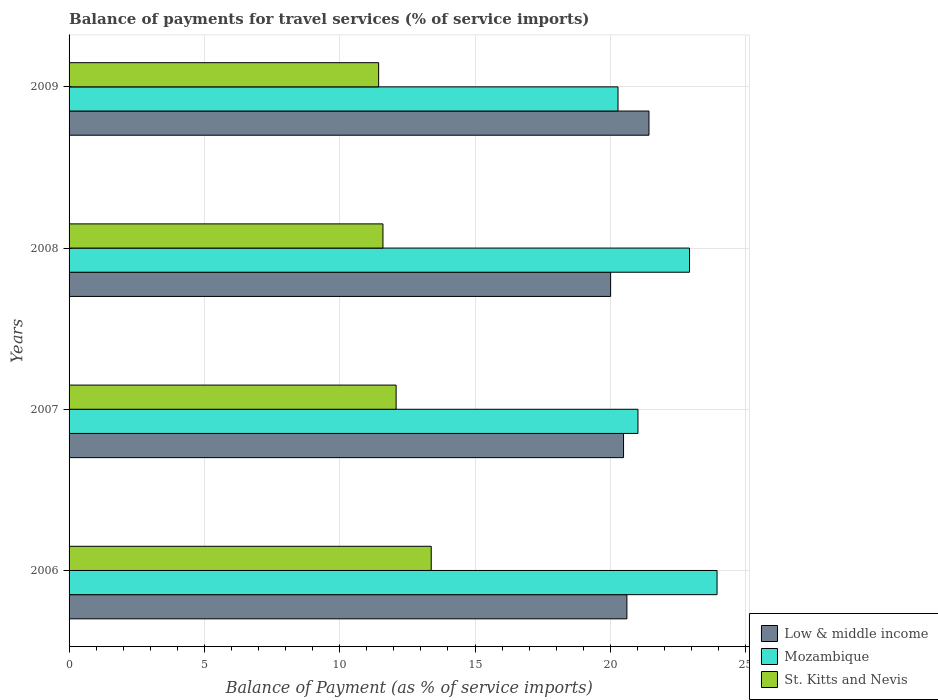How many different coloured bars are there?
Ensure brevity in your answer.  3. How many groups of bars are there?
Your answer should be compact. 4. Are the number of bars on each tick of the Y-axis equal?
Make the answer very short. Yes. How many bars are there on the 1st tick from the top?
Offer a terse response. 3. How many bars are there on the 3rd tick from the bottom?
Offer a terse response. 3. What is the label of the 2nd group of bars from the top?
Your answer should be compact. 2008. In how many cases, is the number of bars for a given year not equal to the number of legend labels?
Your answer should be very brief. 0. What is the balance of payments for travel services in Low & middle income in 2009?
Give a very brief answer. 21.43. Across all years, what is the maximum balance of payments for travel services in St. Kitts and Nevis?
Make the answer very short. 13.38. Across all years, what is the minimum balance of payments for travel services in Mozambique?
Offer a terse response. 20.28. In which year was the balance of payments for travel services in Low & middle income maximum?
Offer a terse response. 2009. What is the total balance of payments for travel services in Low & middle income in the graph?
Your answer should be very brief. 82.53. What is the difference between the balance of payments for travel services in Mozambique in 2006 and that in 2009?
Ensure brevity in your answer.  3.66. What is the difference between the balance of payments for travel services in Mozambique in 2008 and the balance of payments for travel services in St. Kitts and Nevis in 2007?
Ensure brevity in your answer.  10.84. What is the average balance of payments for travel services in Low & middle income per year?
Provide a short and direct response. 20.63. In the year 2006, what is the difference between the balance of payments for travel services in St. Kitts and Nevis and balance of payments for travel services in Mozambique?
Offer a terse response. -10.56. In how many years, is the balance of payments for travel services in St. Kitts and Nevis greater than 4 %?
Offer a terse response. 4. What is the ratio of the balance of payments for travel services in Mozambique in 2007 to that in 2009?
Offer a terse response. 1.04. Is the difference between the balance of payments for travel services in St. Kitts and Nevis in 2008 and 2009 greater than the difference between the balance of payments for travel services in Mozambique in 2008 and 2009?
Make the answer very short. No. What is the difference between the highest and the second highest balance of payments for travel services in Mozambique?
Keep it short and to the point. 1.02. What is the difference between the highest and the lowest balance of payments for travel services in Low & middle income?
Give a very brief answer. 1.42. In how many years, is the balance of payments for travel services in St. Kitts and Nevis greater than the average balance of payments for travel services in St. Kitts and Nevis taken over all years?
Provide a succinct answer. 1. What does the 2nd bar from the top in 2007 represents?
Provide a succinct answer. Mozambique. What does the 1st bar from the bottom in 2006 represents?
Provide a short and direct response. Low & middle income. Is it the case that in every year, the sum of the balance of payments for travel services in Low & middle income and balance of payments for travel services in St. Kitts and Nevis is greater than the balance of payments for travel services in Mozambique?
Your response must be concise. Yes. How many bars are there?
Give a very brief answer. 12. Are all the bars in the graph horizontal?
Ensure brevity in your answer.  Yes. How many years are there in the graph?
Offer a terse response. 4. What is the difference between two consecutive major ticks on the X-axis?
Your response must be concise. 5. What is the title of the graph?
Keep it short and to the point. Balance of payments for travel services (% of service imports). What is the label or title of the X-axis?
Provide a short and direct response. Balance of Payment (as % of service imports). What is the Balance of Payment (as % of service imports) of Low & middle income in 2006?
Ensure brevity in your answer.  20.61. What is the Balance of Payment (as % of service imports) of Mozambique in 2006?
Keep it short and to the point. 23.94. What is the Balance of Payment (as % of service imports) in St. Kitts and Nevis in 2006?
Ensure brevity in your answer.  13.38. What is the Balance of Payment (as % of service imports) in Low & middle income in 2007?
Your answer should be compact. 20.49. What is the Balance of Payment (as % of service imports) of Mozambique in 2007?
Give a very brief answer. 21.02. What is the Balance of Payment (as % of service imports) in St. Kitts and Nevis in 2007?
Make the answer very short. 12.08. What is the Balance of Payment (as % of service imports) in Low & middle income in 2008?
Provide a short and direct response. 20.01. What is the Balance of Payment (as % of service imports) of Mozambique in 2008?
Make the answer very short. 22.92. What is the Balance of Payment (as % of service imports) in St. Kitts and Nevis in 2008?
Provide a succinct answer. 11.6. What is the Balance of Payment (as % of service imports) of Low & middle income in 2009?
Your answer should be very brief. 21.43. What is the Balance of Payment (as % of service imports) of Mozambique in 2009?
Make the answer very short. 20.28. What is the Balance of Payment (as % of service imports) in St. Kitts and Nevis in 2009?
Your answer should be very brief. 11.44. Across all years, what is the maximum Balance of Payment (as % of service imports) of Low & middle income?
Your answer should be very brief. 21.43. Across all years, what is the maximum Balance of Payment (as % of service imports) in Mozambique?
Provide a short and direct response. 23.94. Across all years, what is the maximum Balance of Payment (as % of service imports) in St. Kitts and Nevis?
Provide a succinct answer. 13.38. Across all years, what is the minimum Balance of Payment (as % of service imports) of Low & middle income?
Offer a very short reply. 20.01. Across all years, what is the minimum Balance of Payment (as % of service imports) of Mozambique?
Give a very brief answer. 20.28. Across all years, what is the minimum Balance of Payment (as % of service imports) of St. Kitts and Nevis?
Your response must be concise. 11.44. What is the total Balance of Payment (as % of service imports) of Low & middle income in the graph?
Provide a succinct answer. 82.53. What is the total Balance of Payment (as % of service imports) of Mozambique in the graph?
Offer a terse response. 88.17. What is the total Balance of Payment (as % of service imports) in St. Kitts and Nevis in the graph?
Provide a short and direct response. 48.5. What is the difference between the Balance of Payment (as % of service imports) of Low & middle income in 2006 and that in 2007?
Provide a succinct answer. 0.12. What is the difference between the Balance of Payment (as % of service imports) of Mozambique in 2006 and that in 2007?
Keep it short and to the point. 2.92. What is the difference between the Balance of Payment (as % of service imports) of St. Kitts and Nevis in 2006 and that in 2007?
Your response must be concise. 1.3. What is the difference between the Balance of Payment (as % of service imports) in Low & middle income in 2006 and that in 2008?
Give a very brief answer. 0.6. What is the difference between the Balance of Payment (as % of service imports) in Mozambique in 2006 and that in 2008?
Offer a very short reply. 1.02. What is the difference between the Balance of Payment (as % of service imports) in St. Kitts and Nevis in 2006 and that in 2008?
Your answer should be compact. 1.78. What is the difference between the Balance of Payment (as % of service imports) of Low & middle income in 2006 and that in 2009?
Give a very brief answer. -0.81. What is the difference between the Balance of Payment (as % of service imports) in Mozambique in 2006 and that in 2009?
Give a very brief answer. 3.66. What is the difference between the Balance of Payment (as % of service imports) in St. Kitts and Nevis in 2006 and that in 2009?
Offer a terse response. 1.94. What is the difference between the Balance of Payment (as % of service imports) of Low & middle income in 2007 and that in 2008?
Provide a short and direct response. 0.48. What is the difference between the Balance of Payment (as % of service imports) of Mozambique in 2007 and that in 2008?
Your answer should be compact. -1.9. What is the difference between the Balance of Payment (as % of service imports) of St. Kitts and Nevis in 2007 and that in 2008?
Offer a very short reply. 0.49. What is the difference between the Balance of Payment (as % of service imports) in Low & middle income in 2007 and that in 2009?
Make the answer very short. -0.94. What is the difference between the Balance of Payment (as % of service imports) in Mozambique in 2007 and that in 2009?
Give a very brief answer. 0.74. What is the difference between the Balance of Payment (as % of service imports) in St. Kitts and Nevis in 2007 and that in 2009?
Offer a very short reply. 0.65. What is the difference between the Balance of Payment (as % of service imports) of Low & middle income in 2008 and that in 2009?
Offer a terse response. -1.42. What is the difference between the Balance of Payment (as % of service imports) in Mozambique in 2008 and that in 2009?
Provide a short and direct response. 2.64. What is the difference between the Balance of Payment (as % of service imports) of St. Kitts and Nevis in 2008 and that in 2009?
Provide a succinct answer. 0.16. What is the difference between the Balance of Payment (as % of service imports) of Low & middle income in 2006 and the Balance of Payment (as % of service imports) of Mozambique in 2007?
Your answer should be very brief. -0.41. What is the difference between the Balance of Payment (as % of service imports) of Low & middle income in 2006 and the Balance of Payment (as % of service imports) of St. Kitts and Nevis in 2007?
Ensure brevity in your answer.  8.53. What is the difference between the Balance of Payment (as % of service imports) in Mozambique in 2006 and the Balance of Payment (as % of service imports) in St. Kitts and Nevis in 2007?
Your answer should be very brief. 11.86. What is the difference between the Balance of Payment (as % of service imports) of Low & middle income in 2006 and the Balance of Payment (as % of service imports) of Mozambique in 2008?
Make the answer very short. -2.31. What is the difference between the Balance of Payment (as % of service imports) in Low & middle income in 2006 and the Balance of Payment (as % of service imports) in St. Kitts and Nevis in 2008?
Your answer should be compact. 9.01. What is the difference between the Balance of Payment (as % of service imports) in Mozambique in 2006 and the Balance of Payment (as % of service imports) in St. Kitts and Nevis in 2008?
Your answer should be compact. 12.34. What is the difference between the Balance of Payment (as % of service imports) in Low & middle income in 2006 and the Balance of Payment (as % of service imports) in Mozambique in 2009?
Your answer should be compact. 0.33. What is the difference between the Balance of Payment (as % of service imports) of Low & middle income in 2006 and the Balance of Payment (as % of service imports) of St. Kitts and Nevis in 2009?
Provide a short and direct response. 9.17. What is the difference between the Balance of Payment (as % of service imports) in Mozambique in 2006 and the Balance of Payment (as % of service imports) in St. Kitts and Nevis in 2009?
Your response must be concise. 12.5. What is the difference between the Balance of Payment (as % of service imports) of Low & middle income in 2007 and the Balance of Payment (as % of service imports) of Mozambique in 2008?
Your response must be concise. -2.44. What is the difference between the Balance of Payment (as % of service imports) of Low & middle income in 2007 and the Balance of Payment (as % of service imports) of St. Kitts and Nevis in 2008?
Make the answer very short. 8.89. What is the difference between the Balance of Payment (as % of service imports) of Mozambique in 2007 and the Balance of Payment (as % of service imports) of St. Kitts and Nevis in 2008?
Your answer should be very brief. 9.42. What is the difference between the Balance of Payment (as % of service imports) of Low & middle income in 2007 and the Balance of Payment (as % of service imports) of Mozambique in 2009?
Make the answer very short. 0.2. What is the difference between the Balance of Payment (as % of service imports) in Low & middle income in 2007 and the Balance of Payment (as % of service imports) in St. Kitts and Nevis in 2009?
Make the answer very short. 9.05. What is the difference between the Balance of Payment (as % of service imports) in Mozambique in 2007 and the Balance of Payment (as % of service imports) in St. Kitts and Nevis in 2009?
Your answer should be compact. 9.58. What is the difference between the Balance of Payment (as % of service imports) of Low & middle income in 2008 and the Balance of Payment (as % of service imports) of Mozambique in 2009?
Offer a terse response. -0.27. What is the difference between the Balance of Payment (as % of service imports) of Low & middle income in 2008 and the Balance of Payment (as % of service imports) of St. Kitts and Nevis in 2009?
Ensure brevity in your answer.  8.57. What is the difference between the Balance of Payment (as % of service imports) in Mozambique in 2008 and the Balance of Payment (as % of service imports) in St. Kitts and Nevis in 2009?
Offer a terse response. 11.49. What is the average Balance of Payment (as % of service imports) in Low & middle income per year?
Make the answer very short. 20.63. What is the average Balance of Payment (as % of service imports) in Mozambique per year?
Provide a short and direct response. 22.04. What is the average Balance of Payment (as % of service imports) in St. Kitts and Nevis per year?
Provide a succinct answer. 12.12. In the year 2006, what is the difference between the Balance of Payment (as % of service imports) in Low & middle income and Balance of Payment (as % of service imports) in Mozambique?
Offer a very short reply. -3.33. In the year 2006, what is the difference between the Balance of Payment (as % of service imports) in Low & middle income and Balance of Payment (as % of service imports) in St. Kitts and Nevis?
Provide a short and direct response. 7.23. In the year 2006, what is the difference between the Balance of Payment (as % of service imports) in Mozambique and Balance of Payment (as % of service imports) in St. Kitts and Nevis?
Offer a very short reply. 10.56. In the year 2007, what is the difference between the Balance of Payment (as % of service imports) of Low & middle income and Balance of Payment (as % of service imports) of Mozambique?
Your answer should be very brief. -0.53. In the year 2007, what is the difference between the Balance of Payment (as % of service imports) in Low & middle income and Balance of Payment (as % of service imports) in St. Kitts and Nevis?
Provide a short and direct response. 8.4. In the year 2007, what is the difference between the Balance of Payment (as % of service imports) of Mozambique and Balance of Payment (as % of service imports) of St. Kitts and Nevis?
Provide a short and direct response. 8.94. In the year 2008, what is the difference between the Balance of Payment (as % of service imports) in Low & middle income and Balance of Payment (as % of service imports) in Mozambique?
Offer a very short reply. -2.92. In the year 2008, what is the difference between the Balance of Payment (as % of service imports) in Low & middle income and Balance of Payment (as % of service imports) in St. Kitts and Nevis?
Your response must be concise. 8.41. In the year 2008, what is the difference between the Balance of Payment (as % of service imports) of Mozambique and Balance of Payment (as % of service imports) of St. Kitts and Nevis?
Offer a terse response. 11.33. In the year 2009, what is the difference between the Balance of Payment (as % of service imports) in Low & middle income and Balance of Payment (as % of service imports) in Mozambique?
Offer a terse response. 1.14. In the year 2009, what is the difference between the Balance of Payment (as % of service imports) of Low & middle income and Balance of Payment (as % of service imports) of St. Kitts and Nevis?
Your answer should be very brief. 9.99. In the year 2009, what is the difference between the Balance of Payment (as % of service imports) in Mozambique and Balance of Payment (as % of service imports) in St. Kitts and Nevis?
Provide a succinct answer. 8.84. What is the ratio of the Balance of Payment (as % of service imports) in Low & middle income in 2006 to that in 2007?
Give a very brief answer. 1.01. What is the ratio of the Balance of Payment (as % of service imports) of Mozambique in 2006 to that in 2007?
Ensure brevity in your answer.  1.14. What is the ratio of the Balance of Payment (as % of service imports) of St. Kitts and Nevis in 2006 to that in 2007?
Provide a short and direct response. 1.11. What is the ratio of the Balance of Payment (as % of service imports) of Low & middle income in 2006 to that in 2008?
Keep it short and to the point. 1.03. What is the ratio of the Balance of Payment (as % of service imports) of Mozambique in 2006 to that in 2008?
Make the answer very short. 1.04. What is the ratio of the Balance of Payment (as % of service imports) in St. Kitts and Nevis in 2006 to that in 2008?
Provide a short and direct response. 1.15. What is the ratio of the Balance of Payment (as % of service imports) of Low & middle income in 2006 to that in 2009?
Keep it short and to the point. 0.96. What is the ratio of the Balance of Payment (as % of service imports) of Mozambique in 2006 to that in 2009?
Give a very brief answer. 1.18. What is the ratio of the Balance of Payment (as % of service imports) in St. Kitts and Nevis in 2006 to that in 2009?
Offer a terse response. 1.17. What is the ratio of the Balance of Payment (as % of service imports) of Low & middle income in 2007 to that in 2008?
Provide a succinct answer. 1.02. What is the ratio of the Balance of Payment (as % of service imports) in Mozambique in 2007 to that in 2008?
Your answer should be very brief. 0.92. What is the ratio of the Balance of Payment (as % of service imports) of St. Kitts and Nevis in 2007 to that in 2008?
Provide a short and direct response. 1.04. What is the ratio of the Balance of Payment (as % of service imports) of Low & middle income in 2007 to that in 2009?
Your answer should be very brief. 0.96. What is the ratio of the Balance of Payment (as % of service imports) of Mozambique in 2007 to that in 2009?
Offer a terse response. 1.04. What is the ratio of the Balance of Payment (as % of service imports) in St. Kitts and Nevis in 2007 to that in 2009?
Ensure brevity in your answer.  1.06. What is the ratio of the Balance of Payment (as % of service imports) in Low & middle income in 2008 to that in 2009?
Give a very brief answer. 0.93. What is the ratio of the Balance of Payment (as % of service imports) of Mozambique in 2008 to that in 2009?
Give a very brief answer. 1.13. What is the ratio of the Balance of Payment (as % of service imports) in St. Kitts and Nevis in 2008 to that in 2009?
Offer a terse response. 1.01. What is the difference between the highest and the second highest Balance of Payment (as % of service imports) in Low & middle income?
Provide a succinct answer. 0.81. What is the difference between the highest and the second highest Balance of Payment (as % of service imports) in Mozambique?
Offer a very short reply. 1.02. What is the difference between the highest and the second highest Balance of Payment (as % of service imports) in St. Kitts and Nevis?
Offer a very short reply. 1.3. What is the difference between the highest and the lowest Balance of Payment (as % of service imports) in Low & middle income?
Give a very brief answer. 1.42. What is the difference between the highest and the lowest Balance of Payment (as % of service imports) of Mozambique?
Ensure brevity in your answer.  3.66. What is the difference between the highest and the lowest Balance of Payment (as % of service imports) of St. Kitts and Nevis?
Keep it short and to the point. 1.94. 